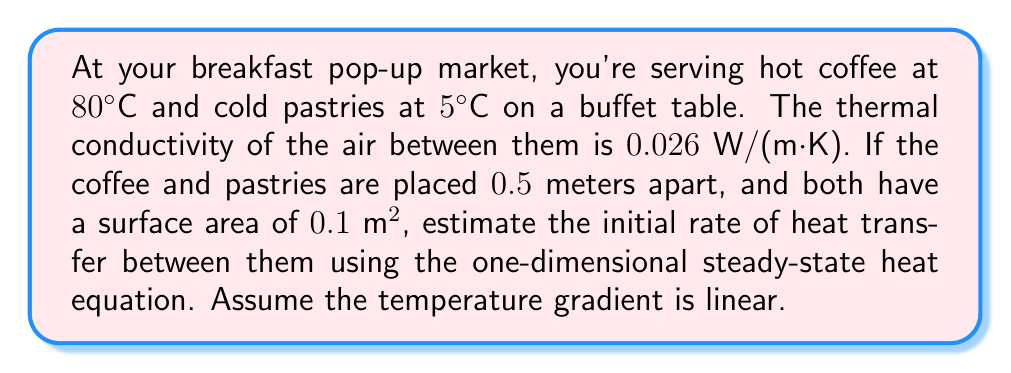Solve this math problem. To solve this problem, we'll use the one-dimensional steady-state heat equation:

$$Q = -kA\frac{dT}{dx}$$

Where:
$Q$ = rate of heat transfer (W)
$k$ = thermal conductivity of air [0.026 W/(m·K)]
$A$ = surface area (0.1 m²)
$\frac{dT}{dx}$ = temperature gradient (K/m)

Steps:
1) Calculate the temperature difference:
   $\Delta T = 80°C - 5°C = 75°C = 75\text{ K}$

2) Calculate the temperature gradient:
   $\frac{dT}{dx} = \frac{\Delta T}{\Delta x} = \frac{75\text{ K}}{0.5\text{ m}} = 150\text{ K/m}$

3) Apply the heat equation:
   $Q = -k \cdot A \cdot \frac{dT}{dx}$
   $Q = -0.026 \frac{\text{W}}{\text{m}\cdot\text{K}} \cdot 0.1\text{ m}^2 \cdot 150\frac{\text{K}}{\text{m}}$
   $Q = -0.39\text{ W}$

The negative sign indicates that heat is flowing from the hot coffee to the cold pastries.
Answer: 0.39 W 